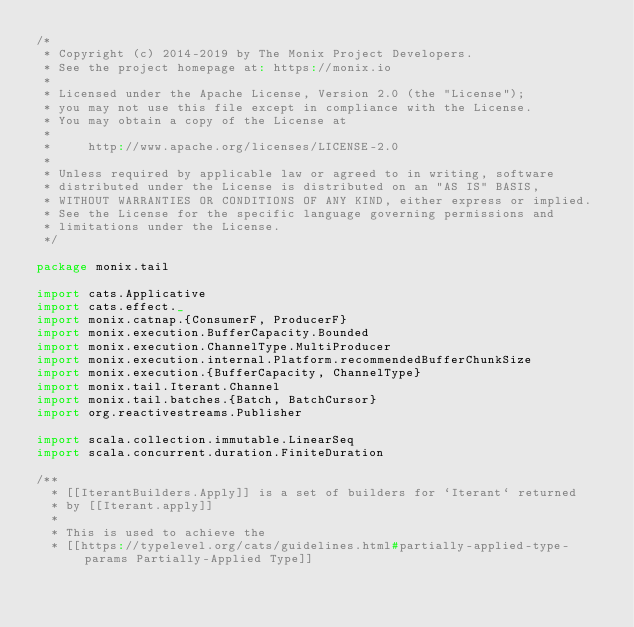Convert code to text. <code><loc_0><loc_0><loc_500><loc_500><_Scala_>/*
 * Copyright (c) 2014-2019 by The Monix Project Developers.
 * See the project homepage at: https://monix.io
 *
 * Licensed under the Apache License, Version 2.0 (the "License");
 * you may not use this file except in compliance with the License.
 * You may obtain a copy of the License at
 *
 *     http://www.apache.org/licenses/LICENSE-2.0
 *
 * Unless required by applicable law or agreed to in writing, software
 * distributed under the License is distributed on an "AS IS" BASIS,
 * WITHOUT WARRANTIES OR CONDITIONS OF ANY KIND, either express or implied.
 * See the License for the specific language governing permissions and
 * limitations under the License.
 */

package monix.tail

import cats.Applicative
import cats.effect._
import monix.catnap.{ConsumerF, ProducerF}
import monix.execution.BufferCapacity.Bounded
import monix.execution.ChannelType.MultiProducer
import monix.execution.internal.Platform.recommendedBufferChunkSize
import monix.execution.{BufferCapacity, ChannelType}
import monix.tail.Iterant.Channel
import monix.tail.batches.{Batch, BatchCursor}
import org.reactivestreams.Publisher

import scala.collection.immutable.LinearSeq
import scala.concurrent.duration.FiniteDuration

/**
  * [[IterantBuilders.Apply]] is a set of builders for `Iterant` returned
  * by [[Iterant.apply]]
  *
  * This is used to achieve the
  * [[https://typelevel.org/cats/guidelines.html#partially-applied-type-params Partially-Applied Type]]</code> 